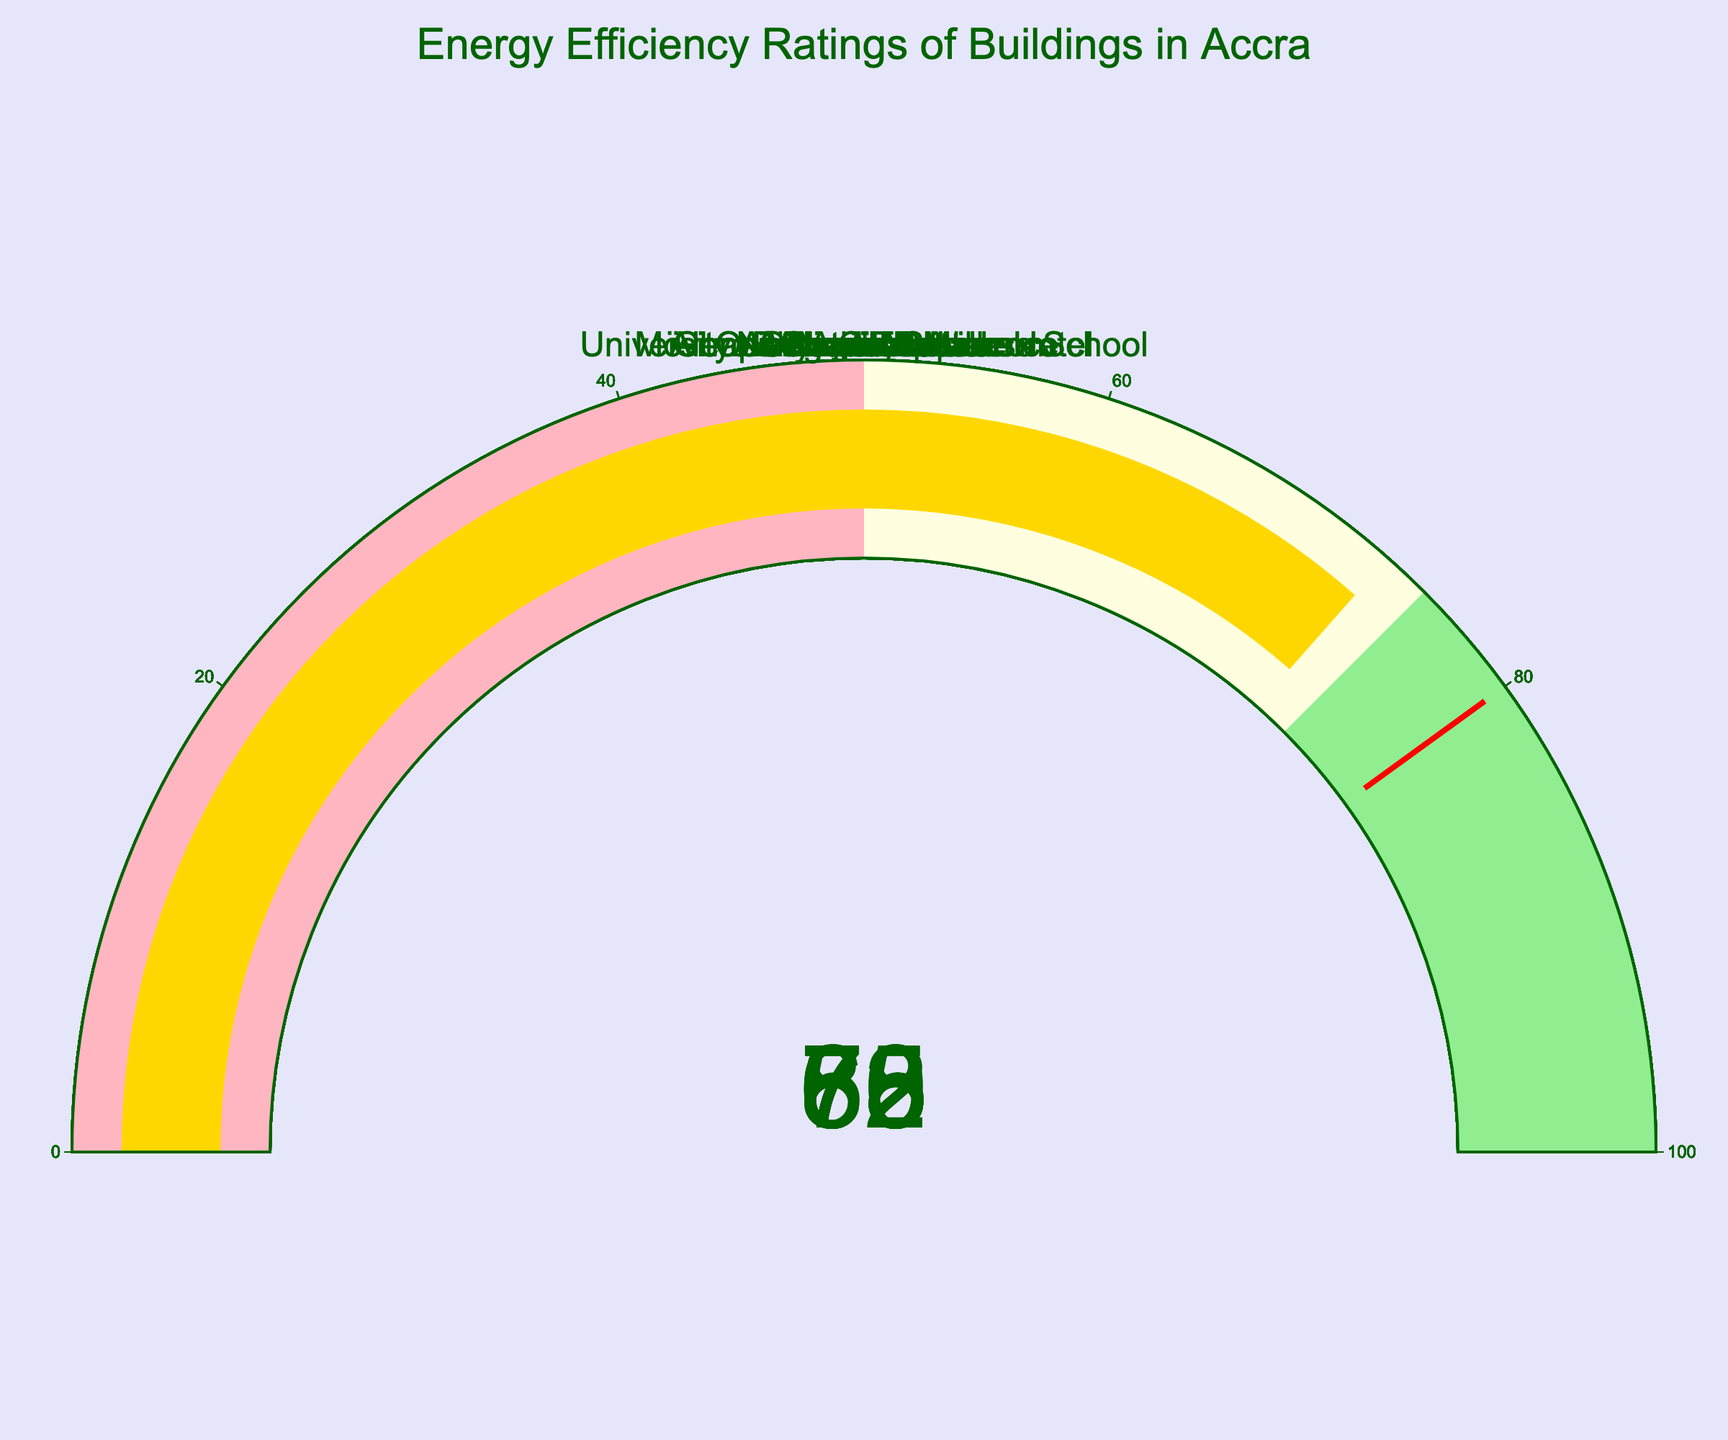what is the highest energy efficiency rating depicted in the gauge chart? The gauge chart shows various buildings and their energy efficiency ratings. By inspecting each gauge, the highest rating can be seen on the gauge for Alero Olympio Residence, which shows 85.
Answer: 85 Which building has the lowest energy efficiency rating? To identify the building with the lowest energy efficiency rating, scan all the gauges for the smallest number. Accra Mall has the lowest rating at 58.
Answer: Accra Mall How many buildings have an energy efficiency rating higher than 70? Count the number of gauges where the energy efficiency rating is greater than 70. These buildings are One Airport Square, Mövenpick Ambassador Hotel, Alero Olympio Residence,Villagio Vista, and Ridge Hospital.
Answer: 5 What is the average energy efficiency rating of the buildings in the chart? Sum all the energy efficiency ratings and divide by the number of buildings. The total is (65 + 58 + 82 + 72 + 70 + 85 + 60 + 75 + 68 + 73) = 708. Dividing by 10 buildings gives 708/10 = 70.8.
Answer: 70.8 Which buildings fall into the highest energy efficiency range (green section on the gauge)? Inspect each gauge for ratings in the range of 75 to 100, which is colored in light green. The buildings in this range are One Airport Square, Alero Olympio Residence, Villagio Vista, and Ridge Hospital.
Answer: One Airport Square, Alero Olympio Residence, Villagio Vista, Ridge Hospital What is the median energy efficiency rating of the buildings? First, list all the ratings in ascending order: 58, 60, 65, 68, 70, 72, 73, 75, 82, 85. The median is the average of the 5th and 6th numbers: (70 + 72) / 2 = 71.
Answer: 71 Which building has an energy efficiency rating closest to the average rating? The average rating is 70.8. Look for the building with the rating closest to 70.8, which is 70 (University of Ghana Business School) or 72 (Mövenpick Ambassador Hotel).
Answer: Mövenpick Ambassador Hotel Do more buildings have energy efficiency ratings above or below the median rating? First, determine the median rating, which is 71. Then count the buildings with ratings above and below this number. Here, there are 5 buildings above 71 and 5 below 71, so they are equal.
Answer: Equal 